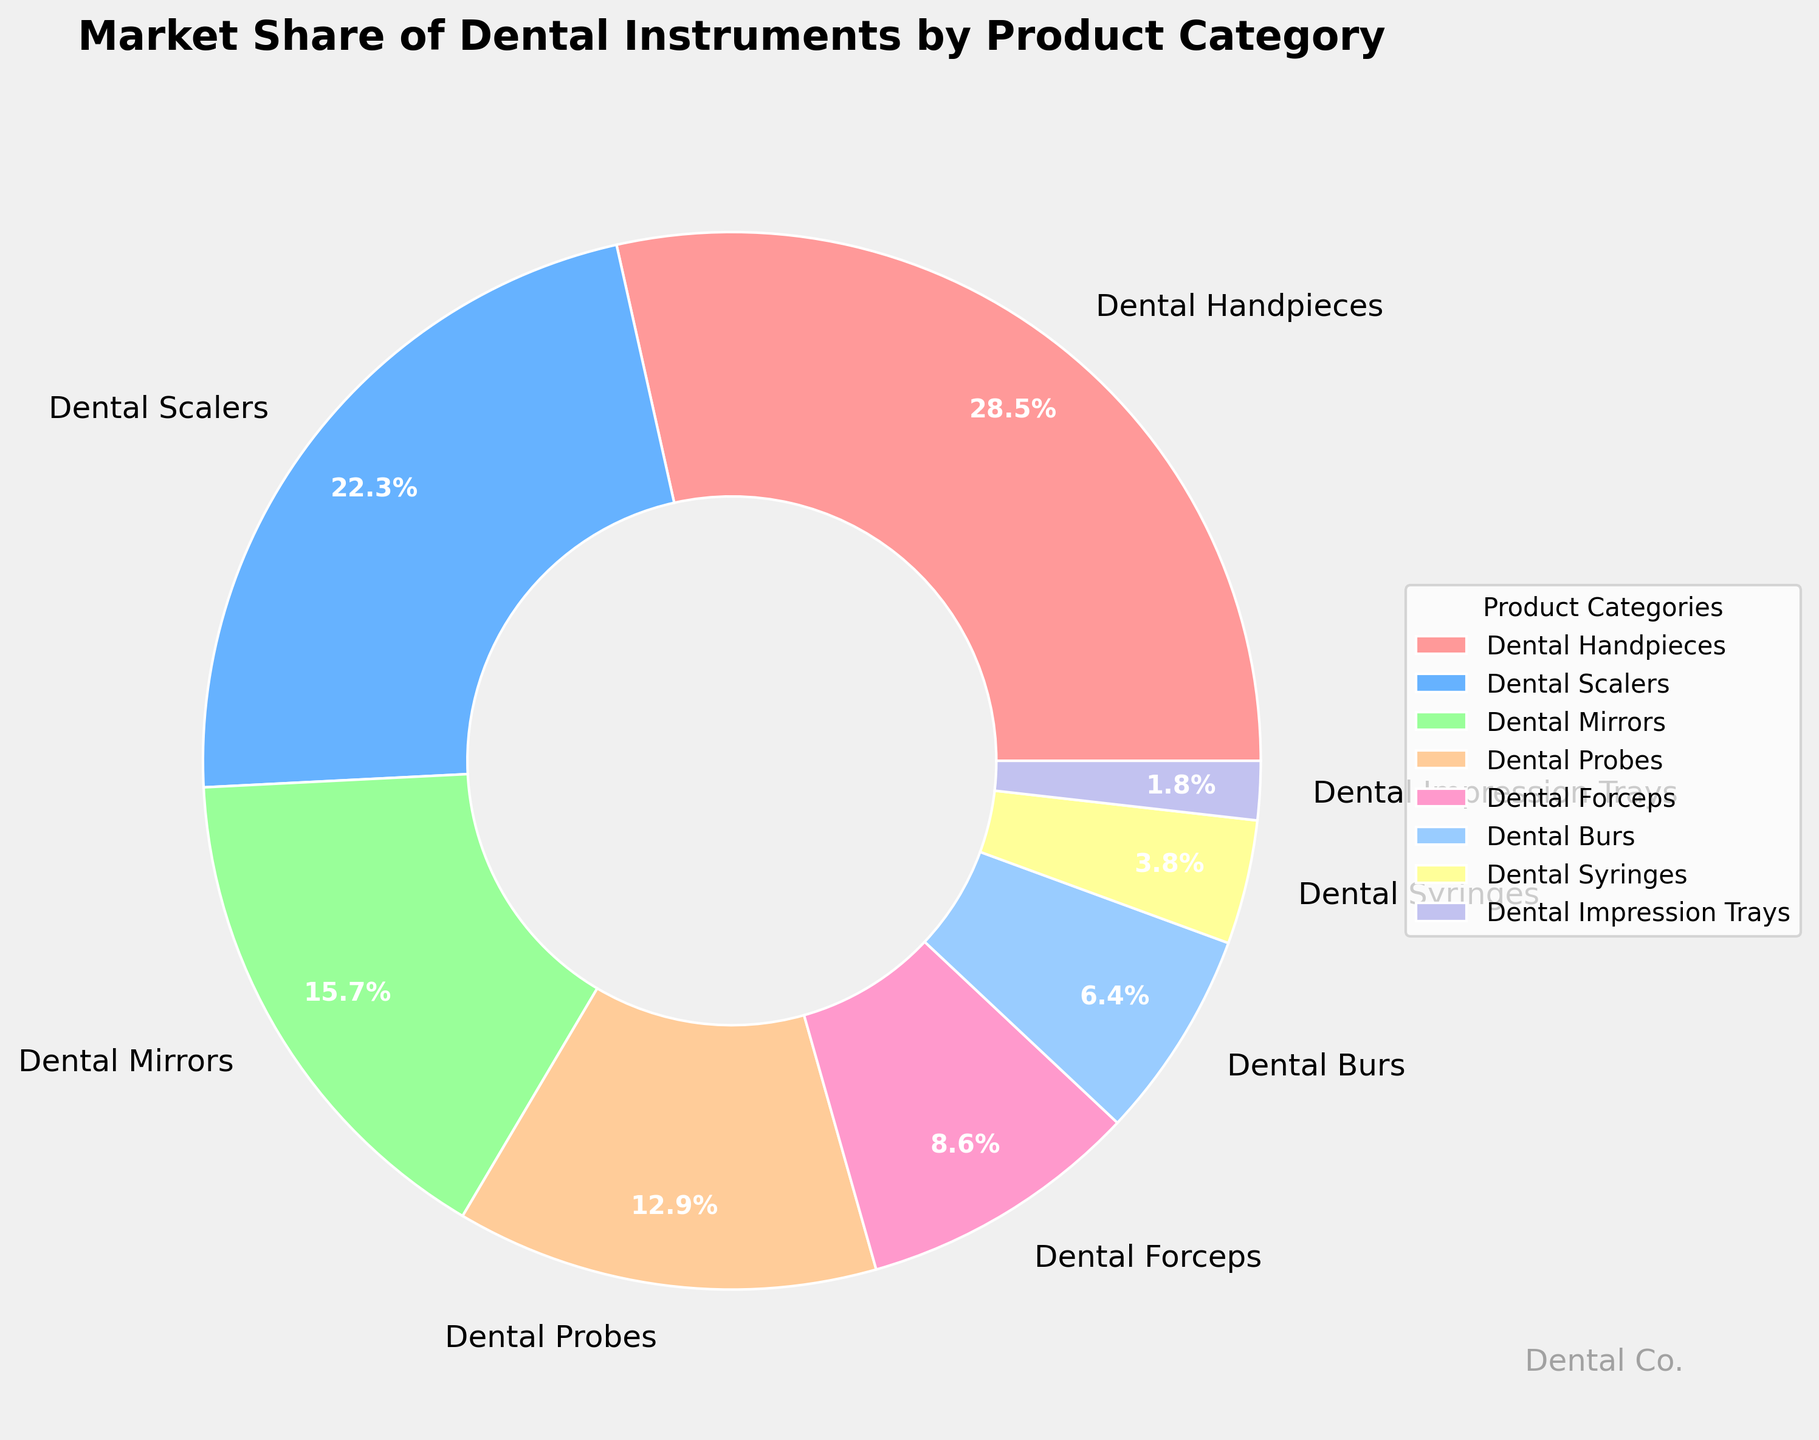What product category has the largest market share? Observe the pie chart and locate the segment with the largest percentage value. In this chart, the largest segment represents "Dental Handpieces" with a market share of 28.5%.
Answer: Dental Handpieces How much more market share does Dental Handpieces have compared to Dental Syringes? Look at the market share percentage for Dental Handpieces (28.5%) and Dental Syringes (3.8%). Calculate the difference: 28.5% - 3.8% = 24.7%.
Answer: 24.7% Which product category has the smallest market share? Identify the smallest segment in the pie chart. The smallest segment represents "Dental Impression Trays" with a market share of 1.8%.
Answer: Dental Impression Trays What is the combined market share of Dental Scalers and Dental Probes? Find the market share percentages for Dental Scalers (22.3%) and Dental Probes (12.9%). Sum these values: 22.3% + 12.9% = 35.2%.
Answer: 35.2% Do Dental Mirrors and Dental Burs together have a higher market share than Dental Handpieces? Find the market share percentages for Dental Mirrors (15.7%) and Dental Burs (6.4%). Sum these values: 15.7% + 6.4% = 22.1%. Compare this sum to the market share of Dental Handpieces (28.5%). 22.1% is less than 28.5%, so the answer is no.
Answer: No Which product categories have a market share greater than 10%? Look at the segments with market share percentages above 10%: Dental Handpieces (28.5%), Dental Scalers (22.3%), Dental Mirrors (15.7%), and Dental Probes (12.9%).
Answer: Dental Handpieces, Dental Scalers, Dental Mirrors, Dental Probes How does the market share of Dental Forceps compare to that of Dental Scalers? Find the market share percentages for Dental Forceps (8.6%) and Dental Scalers (22.3%). Dental Scalers have a larger market share than Dental Forceps.
Answer: Dental Scalers What proportion of the market is occupied by product categories with less than 5% market share? Identify the product categories with market shares less than 5%: Dental Syringes (3.8%) and Dental Impression Trays (1.8%). Sum these values: 3.8% + 1.8% = 5.6%.
Answer: 5.6% What is the average market share of the product categories listed? Sum all the market share percentages: 28.5 + 22.3 + 15.7 + 12.9 + 8.6 + 6.4 + 3.8 + 1.8 = 100%. There are 8 product categories. Calculate the average market share by dividing the total by the number of categories: 100% / 8 = 12.5%.
Answer: 12.5% Between Dental Mirrors and Dental Probes, which segment uses a green color in the pie chart? Locate the specific colors assigned to each product category segment in the pie chart. "Dental Mirrors" is represented by the color (#99FF99 which is a greenish tint).
Answer: Dental Mirrors 